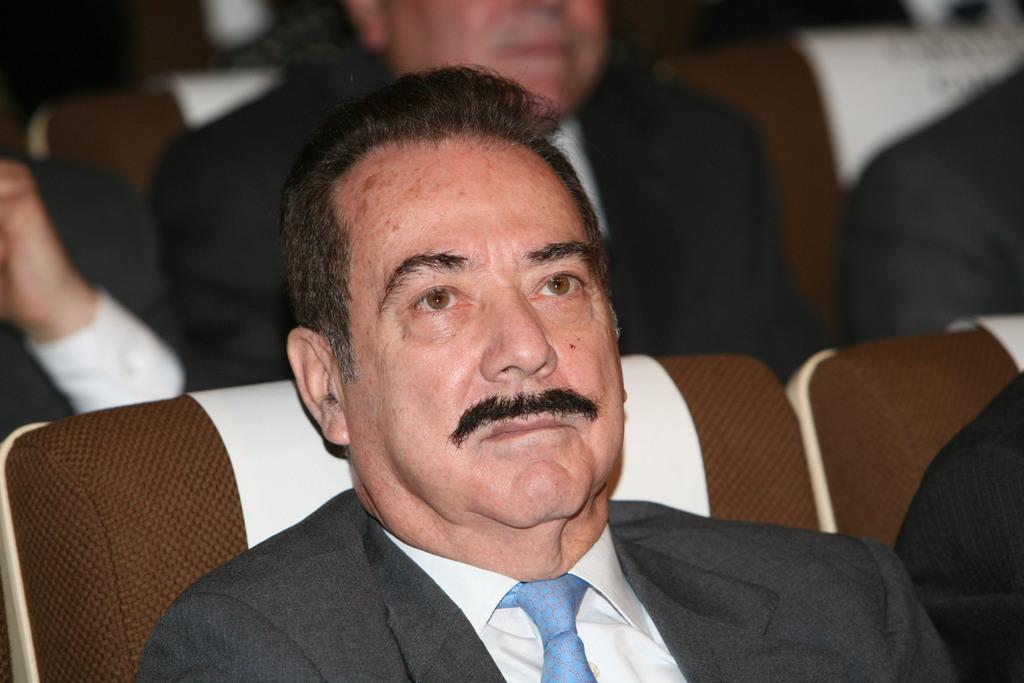What is the man in the image doing? The man is sitting in the sofa. What is the man wearing? The man is wearing a coat. Can you describe the background of the image? There are men in the background of the image. What type of produce can be seen on the man's lap in the image? There is no produce visible on the man's lap in the image. 